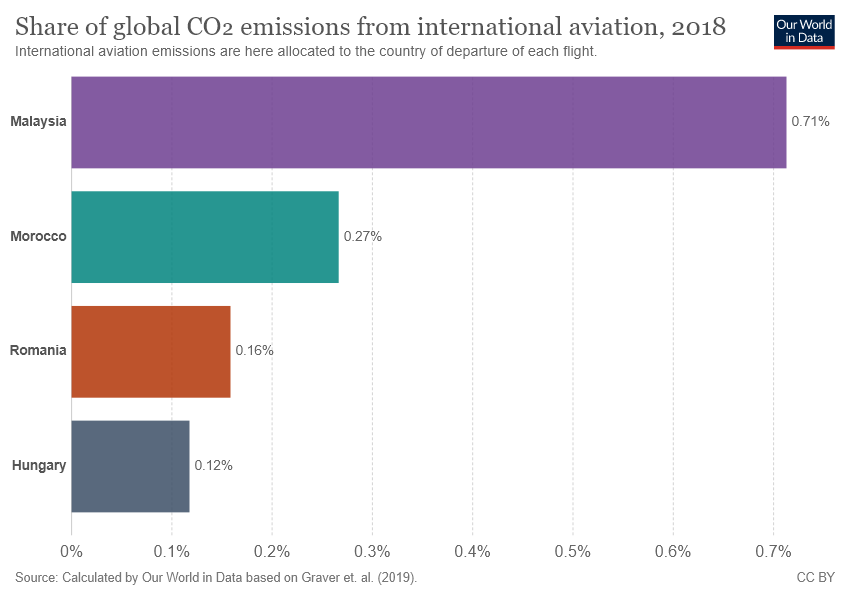Draw attention to some important aspects in this diagram. The difference in value between Romania and Hungary is 0.04. The value of 0.27 percent belongs to Morocco. 